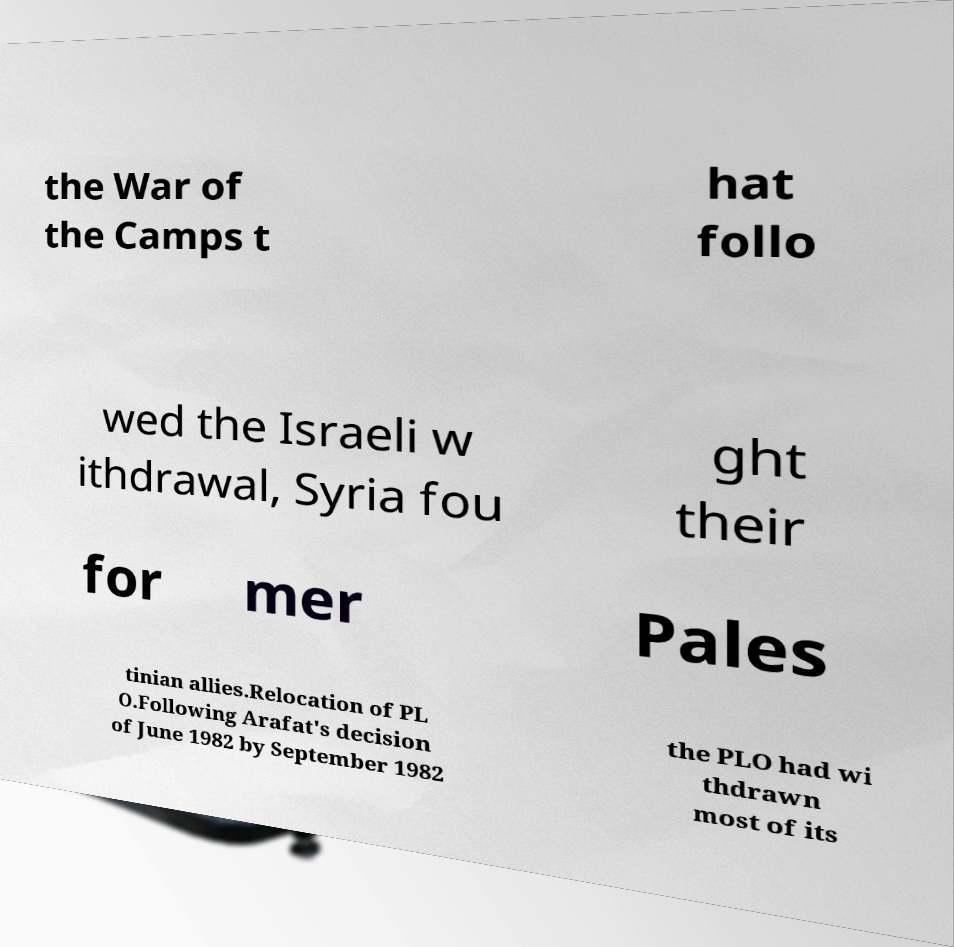There's text embedded in this image that I need extracted. Can you transcribe it verbatim? the War of the Camps t hat follo wed the Israeli w ithdrawal, Syria fou ght their for mer Pales tinian allies.Relocation of PL O.Following Arafat's decision of June 1982 by September 1982 the PLO had wi thdrawn most of its 